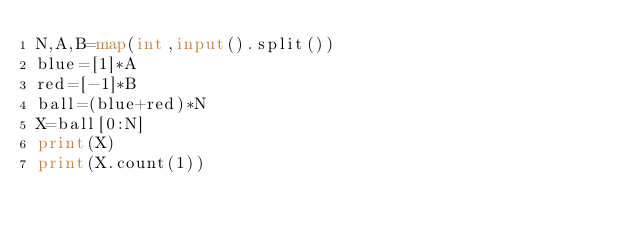Convert code to text. <code><loc_0><loc_0><loc_500><loc_500><_Python_>N,A,B=map(int,input().split())
blue=[1]*A
red=[-1]*B
ball=(blue+red)*N
X=ball[0:N]
print(X)
print(X.count(1))</code> 